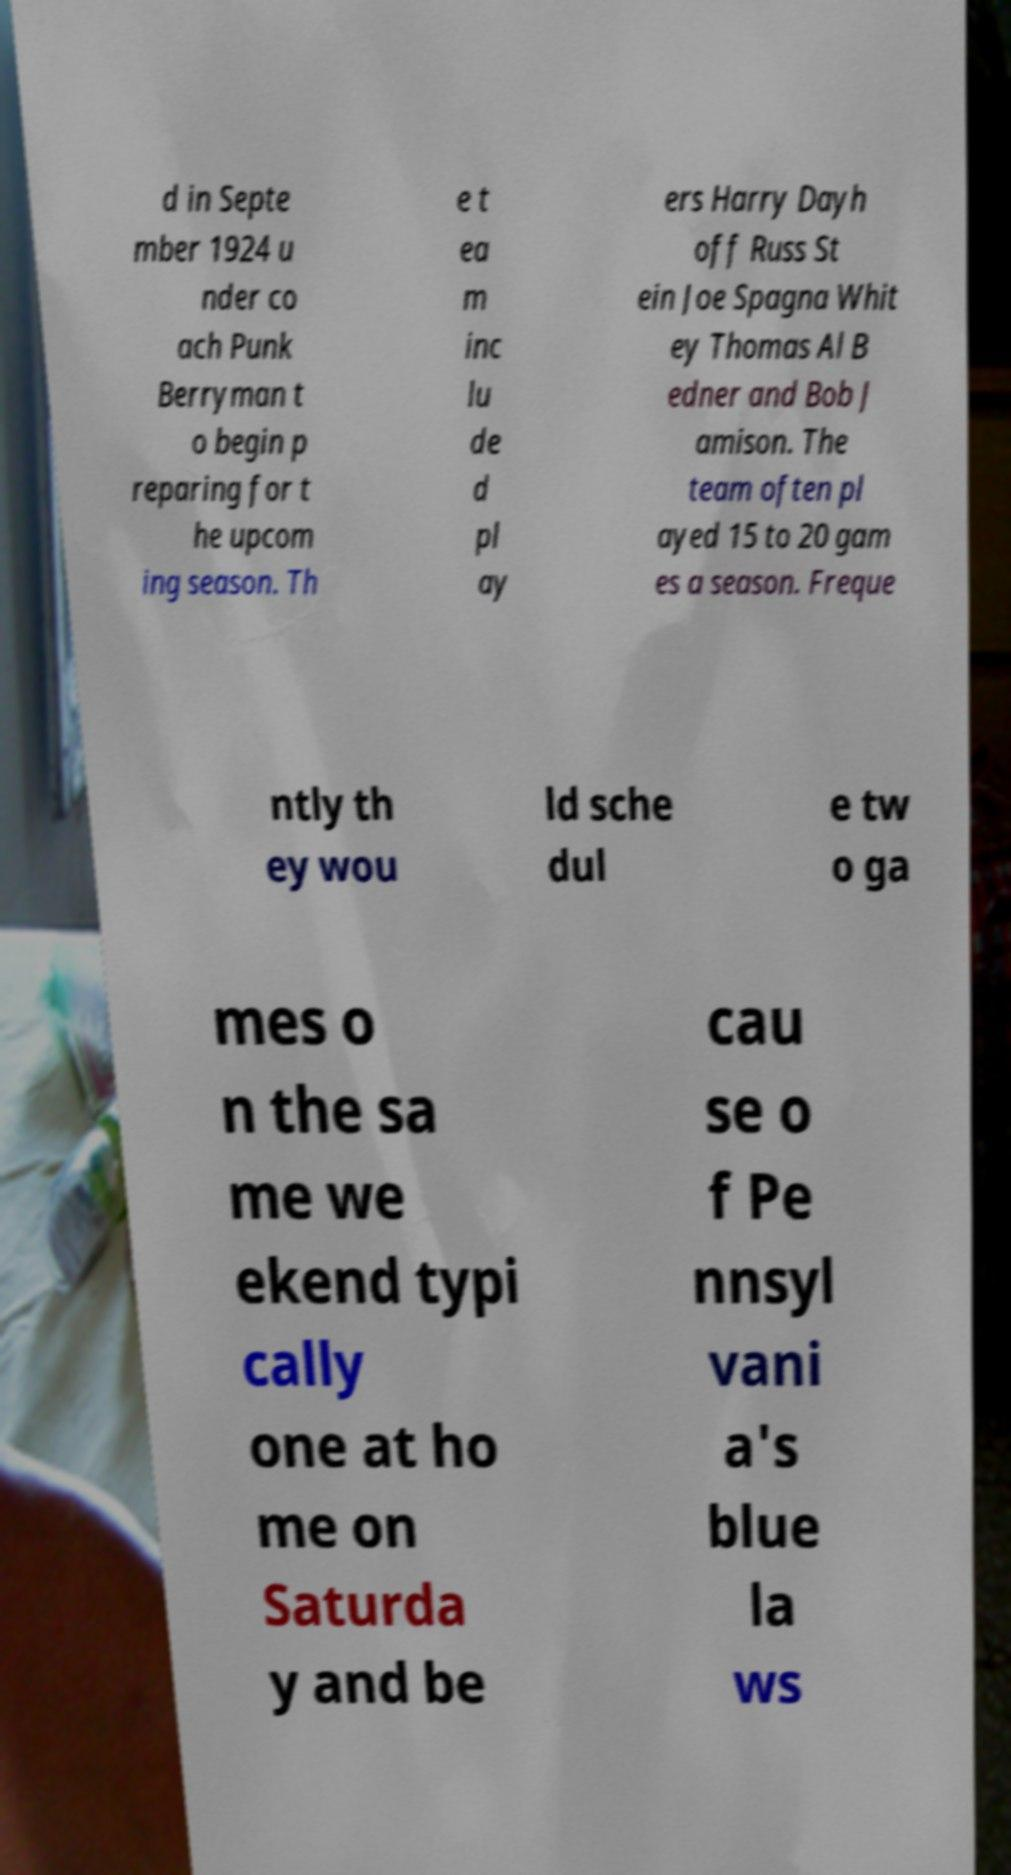Can you read and provide the text displayed in the image?This photo seems to have some interesting text. Can you extract and type it out for me? d in Septe mber 1924 u nder co ach Punk Berryman t o begin p reparing for t he upcom ing season. Th e t ea m inc lu de d pl ay ers Harry Dayh off Russ St ein Joe Spagna Whit ey Thomas Al B edner and Bob J amison. The team often pl ayed 15 to 20 gam es a season. Freque ntly th ey wou ld sche dul e tw o ga mes o n the sa me we ekend typi cally one at ho me on Saturda y and be cau se o f Pe nnsyl vani a's blue la ws 